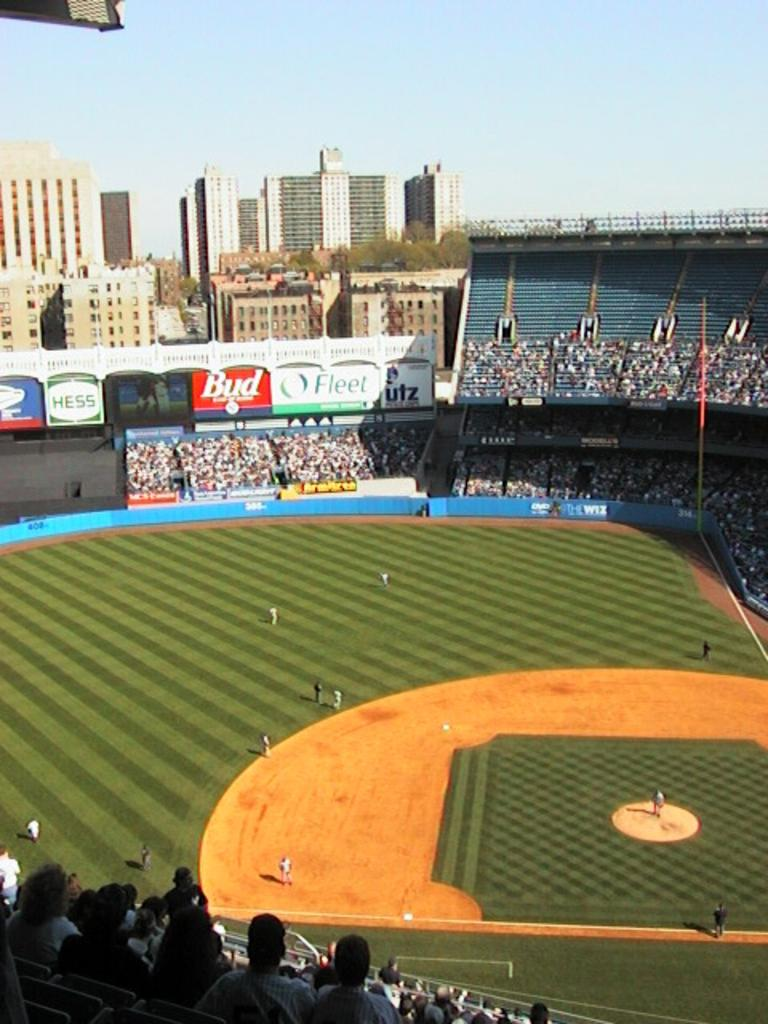<image>
Offer a succinct explanation of the picture presented. On the walls above the baseball stadium are banners sponsored by Hess, Bud and Fleet. 